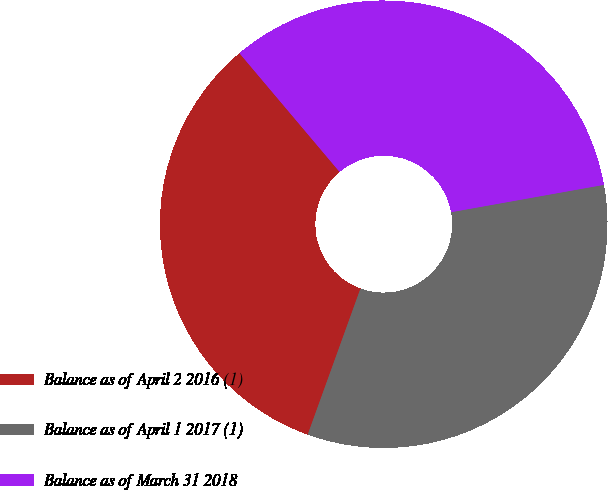Convert chart to OTSL. <chart><loc_0><loc_0><loc_500><loc_500><pie_chart><fcel>Balance as of April 2 2016 (1)<fcel>Balance as of April 1 2017 (1)<fcel>Balance as of March 31 2018<nl><fcel>33.33%<fcel>33.33%<fcel>33.33%<nl></chart> 